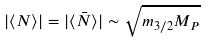Convert formula to latex. <formula><loc_0><loc_0><loc_500><loc_500>| \langle N \rangle | = | \langle \bar { N } \rangle | \sim \sqrt { m _ { 3 / 2 } M _ { P } }</formula> 